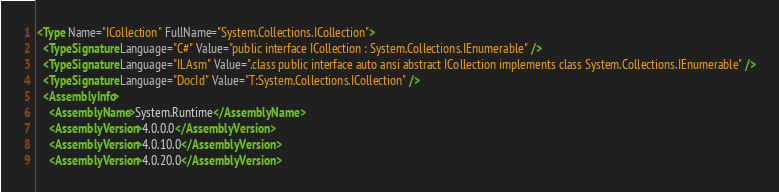Convert code to text. <code><loc_0><loc_0><loc_500><loc_500><_XML_><Type Name="ICollection" FullName="System.Collections.ICollection">
  <TypeSignature Language="C#" Value="public interface ICollection : System.Collections.IEnumerable" />
  <TypeSignature Language="ILAsm" Value=".class public interface auto ansi abstract ICollection implements class System.Collections.IEnumerable" />
  <TypeSignature Language="DocId" Value="T:System.Collections.ICollection" />
  <AssemblyInfo>
    <AssemblyName>System.Runtime</AssemblyName>
    <AssemblyVersion>4.0.0.0</AssemblyVersion>
    <AssemblyVersion>4.0.10.0</AssemblyVersion>
    <AssemblyVersion>4.0.20.0</AssemblyVersion></code> 